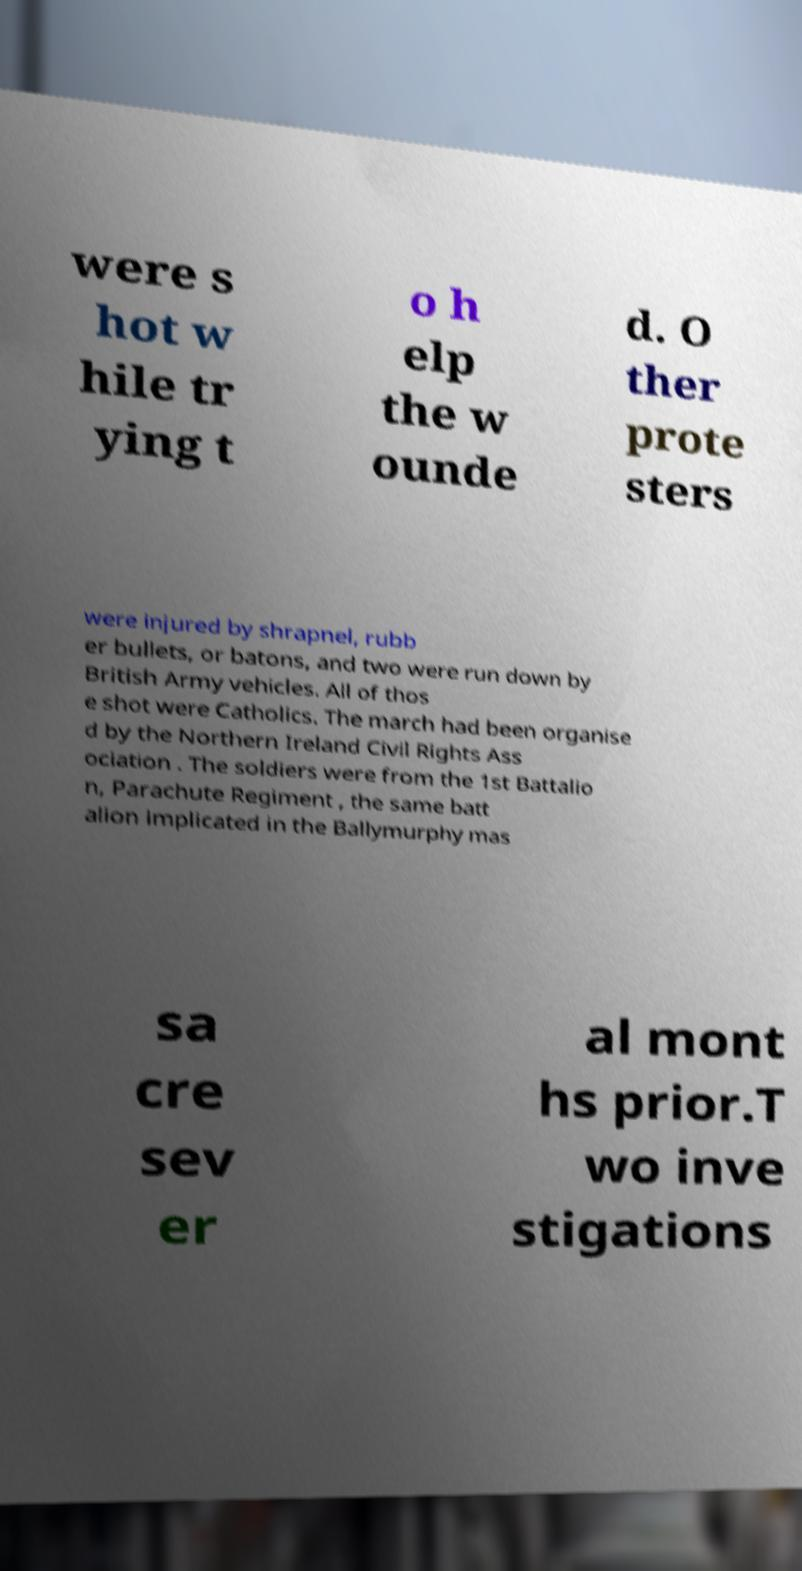For documentation purposes, I need the text within this image transcribed. Could you provide that? were s hot w hile tr ying t o h elp the w ounde d. O ther prote sters were injured by shrapnel, rubb er bullets, or batons, and two were run down by British Army vehicles. All of thos e shot were Catholics. The march had been organise d by the Northern Ireland Civil Rights Ass ociation . The soldiers were from the 1st Battalio n, Parachute Regiment , the same batt alion implicated in the Ballymurphy mas sa cre sev er al mont hs prior.T wo inve stigations 